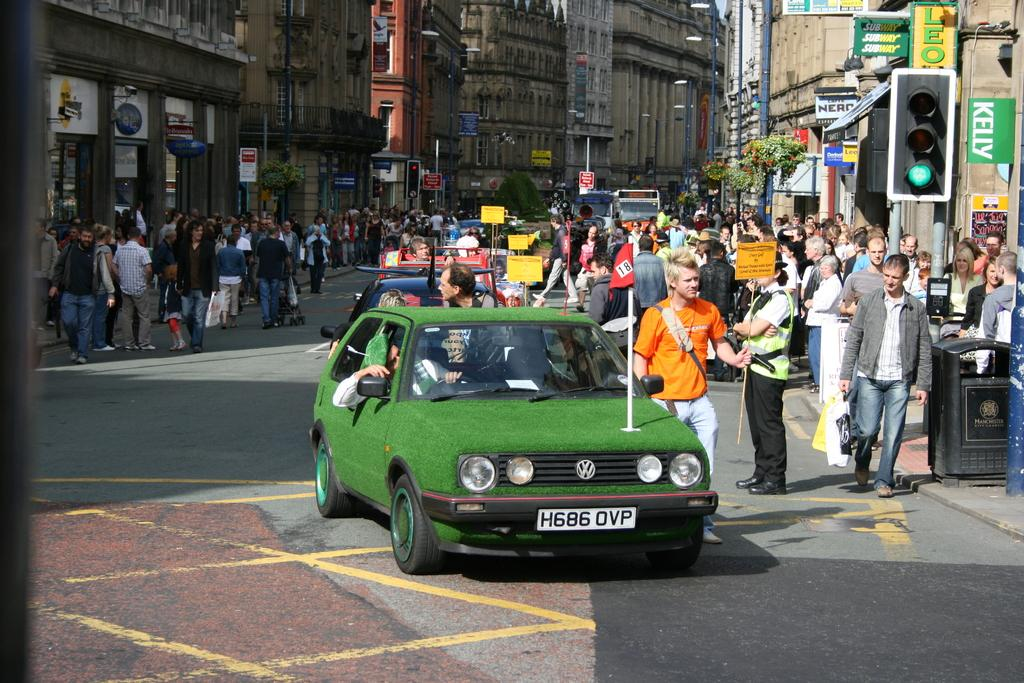<image>
Render a clear and concise summary of the photo. A green car with a VW emblem on the grill is stopped by a sidewalk full of pedestrians. 